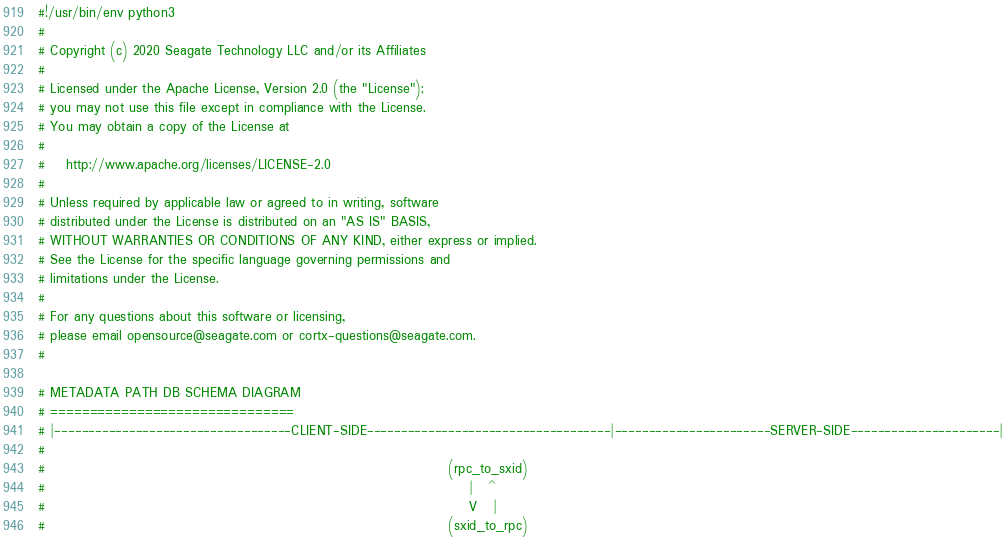Convert code to text. <code><loc_0><loc_0><loc_500><loc_500><_Python_>#!/usr/bin/env python3
#
# Copyright (c) 2020 Seagate Technology LLC and/or its Affiliates
#
# Licensed under the Apache License, Version 2.0 (the "License");
# you may not use this file except in compliance with the License.
# You may obtain a copy of the License at
#
#    http://www.apache.org/licenses/LICENSE-2.0
#
# Unless required by applicable law or agreed to in writing, software
# distributed under the License is distributed on an "AS IS" BASIS,
# WITHOUT WARRANTIES OR CONDITIONS OF ANY KIND, either express or implied.
# See the License for the specific language governing permissions and
# limitations under the License.
#
# For any questions about this software or licensing,
# please email opensource@seagate.com or cortx-questions@seagate.com.
#

# METADATA PATH DB SCHEMA DIAGRAM
# ===============================
# |-----------------------------------CLIENT-SIDE------------------------------------|-----------------------SERVER-SIDE----------------------|
#
#                                                                              (rpc_to_sxid)
#                                                                                  |   ^
#                                                                                  V   |
#                                                                              (sxid_to_rpc)</code> 